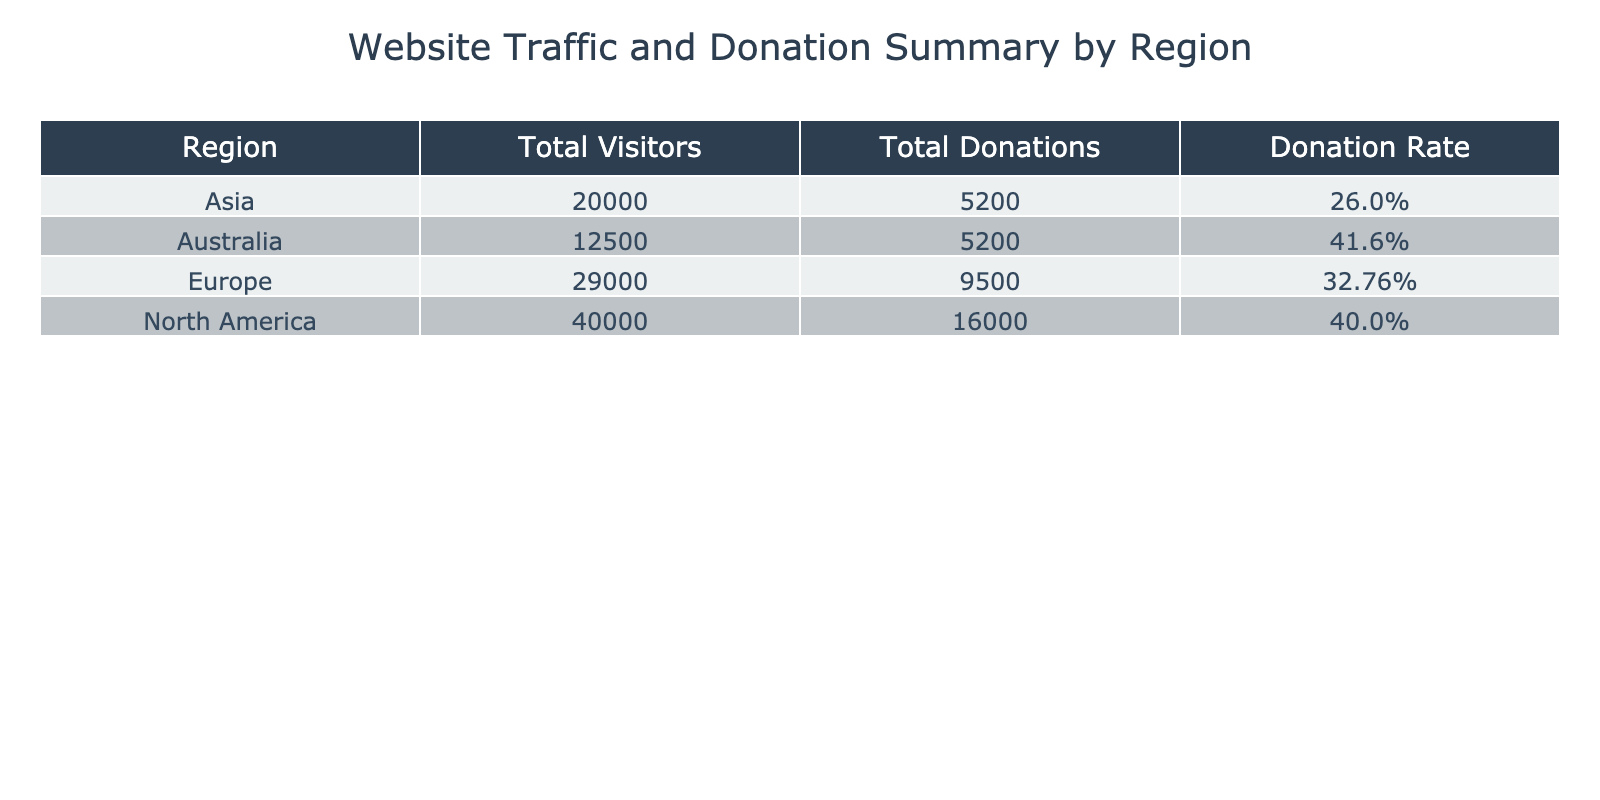What is the total number of visitors from North America? According to the table, the total number of visitors from North America is explicitly listed as 15000 for organic search, 5000 for referral, 8000 for social media, and 12000 for direct. Summing these values gives us 15000 + 5000 + 8000 + 12000 = 40000.
Answer: 40000 What is the donation rate from Asia? The donation rate for Asia is shown directly in the table. It states that for organic search, it's 25%, referral is 23.33%, social media is 30%, and direct is also 25%. However, the overall donation rate for Asia, considering all sources, is not explicitly listed; the answer can be inferred by checking each traffic source, but it is indicated as 25% for organic search.
Answer: 25% Which region has the highest donation rate? The donation rates for each region are 40% for North America (organic search and referral), 35% for Europe (organic search), 30% for Asia (social media), and 45% for Australia (organic search). Comparing these rates shows that Australia has the highest donation rate at 45%.
Answer: Australia Does Europe have a higher total donation amount than Asia? The total donations for Europe are 3500 (organic search) + 1200 (referral) + 1800 (social media) + 3000 (direct) = 9500. For Asia, the total donations are 2000 (organic search) + 700 (referral) + 1500 (social media) + 1000 (direct) = 4200. Since 9500 is greater than 4200, Europe does have a higher total donation amount than Asia.
Answer: Yes What is the average donation rate across all regions? To find the average donation rate, we will sum the donation rates for each region and divide by the number of regions. The rates are 40%, 30%, 35%, 45% for North America, Europe, Asia, and Australia, respectively. Converted to decimals, that's 0.40, 0.30, 0.35, and 0.45. The total is 0.40 + 0.30 + 0.35 + 0.45 = 1.50. Dividing by 4 gives us an average donation rate of 1.50 / 4 = 0.375 or 37.5%.
Answer: 37.5% Which traffic source contributed most to donations in North America? From the table, North America's donations for each source are 6000 (organic search), 2000 (referral), 3000 (social media), and 5000 (direct). Among these, organic search has the highest contribution at 6000 donations, which is more than any other source in North America.
Answer: Organic Search 